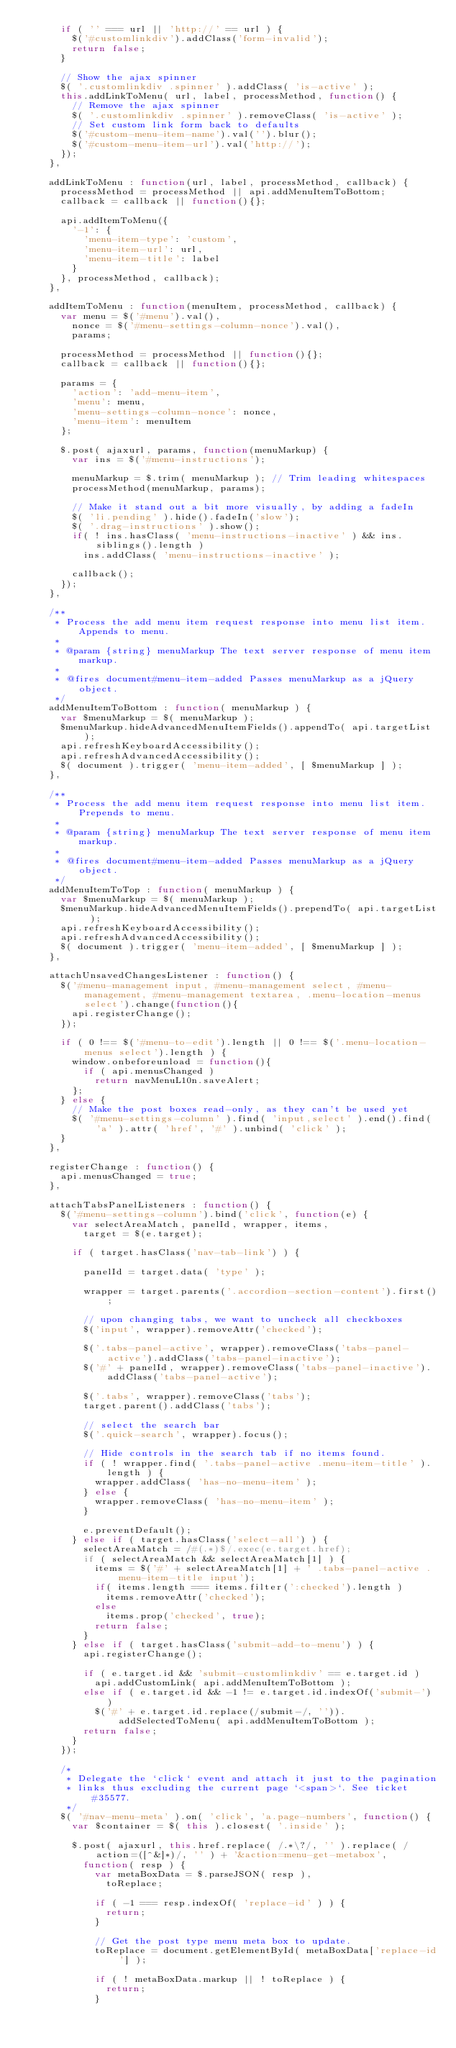Convert code to text. <code><loc_0><loc_0><loc_500><loc_500><_JavaScript_>			if ( '' === url || 'http://' == url ) {
				$('#customlinkdiv').addClass('form-invalid');
				return false;
			}

			// Show the ajax spinner
			$( '.customlinkdiv .spinner' ).addClass( 'is-active' );
			this.addLinkToMenu( url, label, processMethod, function() {
				// Remove the ajax spinner
				$( '.customlinkdiv .spinner' ).removeClass( 'is-active' );
				// Set custom link form back to defaults
				$('#custom-menu-item-name').val('').blur();
				$('#custom-menu-item-url').val('http://');
			});
		},

		addLinkToMenu : function(url, label, processMethod, callback) {
			processMethod = processMethod || api.addMenuItemToBottom;
			callback = callback || function(){};

			api.addItemToMenu({
				'-1': {
					'menu-item-type': 'custom',
					'menu-item-url': url,
					'menu-item-title': label
				}
			}, processMethod, callback);
		},

		addItemToMenu : function(menuItem, processMethod, callback) {
			var menu = $('#menu').val(),
				nonce = $('#menu-settings-column-nonce').val(),
				params;

			processMethod = processMethod || function(){};
			callback = callback || function(){};

			params = {
				'action': 'add-menu-item',
				'menu': menu,
				'menu-settings-column-nonce': nonce,
				'menu-item': menuItem
			};

			$.post( ajaxurl, params, function(menuMarkup) {
				var ins = $('#menu-instructions');

				menuMarkup = $.trim( menuMarkup ); // Trim leading whitespaces
				processMethod(menuMarkup, params);

				// Make it stand out a bit more visually, by adding a fadeIn
				$( 'li.pending' ).hide().fadeIn('slow');
				$( '.drag-instructions' ).show();
				if( ! ins.hasClass( 'menu-instructions-inactive' ) && ins.siblings().length )
					ins.addClass( 'menu-instructions-inactive' );

				callback();
			});
		},

		/**
		 * Process the add menu item request response into menu list item. Appends to menu.
		 *
		 * @param {string} menuMarkup The text server response of menu item markup.
		 *
		 * @fires document#menu-item-added Passes menuMarkup as a jQuery object.
		 */
		addMenuItemToBottom : function( menuMarkup ) {
			var $menuMarkup = $( menuMarkup );
			$menuMarkup.hideAdvancedMenuItemFields().appendTo( api.targetList );
			api.refreshKeyboardAccessibility();
			api.refreshAdvancedAccessibility();
			$( document ).trigger( 'menu-item-added', [ $menuMarkup ] );
		},

		/**
		 * Process the add menu item request response into menu list item. Prepends to menu.
		 *
		 * @param {string} menuMarkup The text server response of menu item markup.
		 *
		 * @fires document#menu-item-added Passes menuMarkup as a jQuery object.
		 */
		addMenuItemToTop : function( menuMarkup ) {
			var $menuMarkup = $( menuMarkup );
			$menuMarkup.hideAdvancedMenuItemFields().prependTo( api.targetList );
			api.refreshKeyboardAccessibility();
			api.refreshAdvancedAccessibility();
			$( document ).trigger( 'menu-item-added', [ $menuMarkup ] );
		},

		attachUnsavedChangesListener : function() {
			$('#menu-management input, #menu-management select, #menu-management, #menu-management textarea, .menu-location-menus select').change(function(){
				api.registerChange();
			});

			if ( 0 !== $('#menu-to-edit').length || 0 !== $('.menu-location-menus select').length ) {
				window.onbeforeunload = function(){
					if ( api.menusChanged )
						return navMenuL10n.saveAlert;
				};
			} else {
				// Make the post boxes read-only, as they can't be used yet
				$( '#menu-settings-column' ).find( 'input,select' ).end().find( 'a' ).attr( 'href', '#' ).unbind( 'click' );
			}
		},

		registerChange : function() {
			api.menusChanged = true;
		},

		attachTabsPanelListeners : function() {
			$('#menu-settings-column').bind('click', function(e) {
				var selectAreaMatch, panelId, wrapper, items,
					target = $(e.target);

				if ( target.hasClass('nav-tab-link') ) {

					panelId = target.data( 'type' );

					wrapper = target.parents('.accordion-section-content').first();

					// upon changing tabs, we want to uncheck all checkboxes
					$('input', wrapper).removeAttr('checked');

					$('.tabs-panel-active', wrapper).removeClass('tabs-panel-active').addClass('tabs-panel-inactive');
					$('#' + panelId, wrapper).removeClass('tabs-panel-inactive').addClass('tabs-panel-active');

					$('.tabs', wrapper).removeClass('tabs');
					target.parent().addClass('tabs');

					// select the search bar
					$('.quick-search', wrapper).focus();

					// Hide controls in the search tab if no items found.
					if ( ! wrapper.find( '.tabs-panel-active .menu-item-title' ).length ) {
						wrapper.addClass( 'has-no-menu-item' );
					} else {
						wrapper.removeClass( 'has-no-menu-item' );
					}

					e.preventDefault();
				} else if ( target.hasClass('select-all') ) {
					selectAreaMatch = /#(.*)$/.exec(e.target.href);
					if ( selectAreaMatch && selectAreaMatch[1] ) {
						items = $('#' + selectAreaMatch[1] + ' .tabs-panel-active .menu-item-title input');
						if( items.length === items.filter(':checked').length )
							items.removeAttr('checked');
						else
							items.prop('checked', true);
						return false;
					}
				} else if ( target.hasClass('submit-add-to-menu') ) {
					api.registerChange();

					if ( e.target.id && 'submit-customlinkdiv' == e.target.id )
						api.addCustomLink( api.addMenuItemToBottom );
					else if ( e.target.id && -1 != e.target.id.indexOf('submit-') )
						$('#' + e.target.id.replace(/submit-/, '')).addSelectedToMenu( api.addMenuItemToBottom );
					return false;
				}
			});

			/*
			 * Delegate the `click` event and attach it just to the pagination
			 * links thus excluding the current page `<span>`. See ticket #35577.
			 */
			$( '#nav-menu-meta' ).on( 'click', 'a.page-numbers', function() {
				var $container = $( this ).closest( '.inside' );

				$.post( ajaxurl, this.href.replace( /.*\?/, '' ).replace( /action=([^&]*)/, '' ) + '&action=menu-get-metabox',
					function( resp ) {
						var metaBoxData = $.parseJSON( resp ),
							toReplace;

						if ( -1 === resp.indexOf( 'replace-id' ) ) {
							return;
						}

						// Get the post type menu meta box to update.
						toReplace = document.getElementById( metaBoxData['replace-id'] );

						if ( ! metaBoxData.markup || ! toReplace ) {
							return;
						}
</code> 